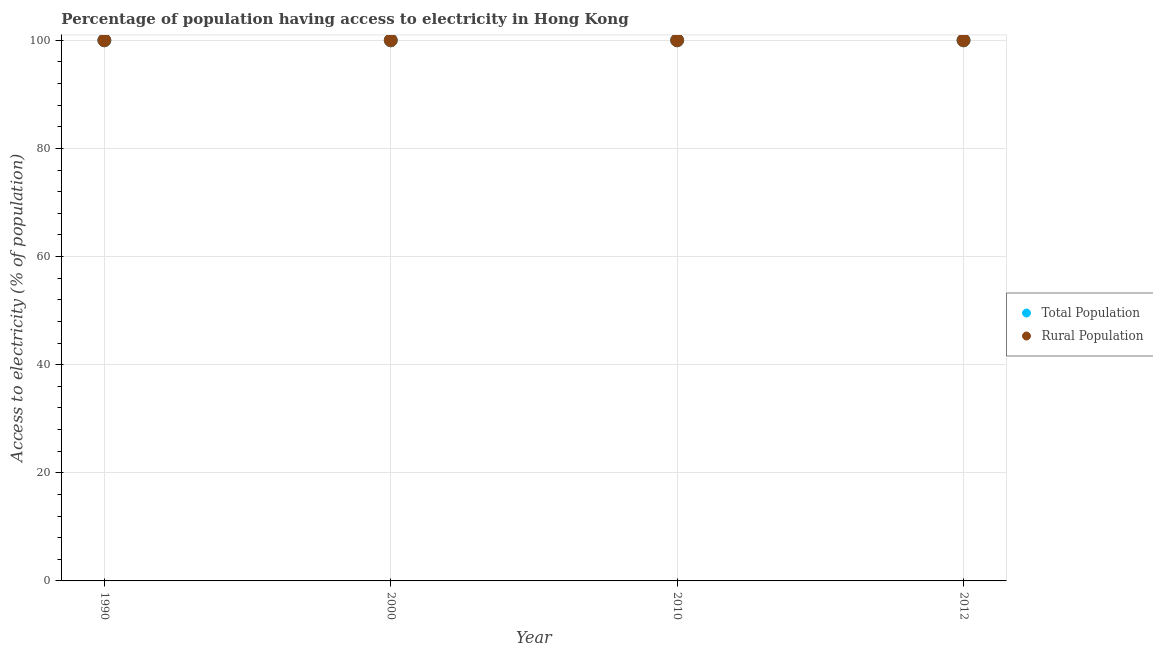How many different coloured dotlines are there?
Make the answer very short. 2. What is the percentage of population having access to electricity in 1990?
Keep it short and to the point. 100. Across all years, what is the maximum percentage of rural population having access to electricity?
Ensure brevity in your answer.  100. Across all years, what is the minimum percentage of population having access to electricity?
Offer a terse response. 100. In which year was the percentage of population having access to electricity maximum?
Make the answer very short. 1990. What is the total percentage of rural population having access to electricity in the graph?
Provide a succinct answer. 400. What is the difference between the percentage of rural population having access to electricity in 1990 and that in 2012?
Offer a terse response. 0. What is the difference between the percentage of rural population having access to electricity in 2010 and the percentage of population having access to electricity in 2000?
Offer a very short reply. 0. What is the average percentage of population having access to electricity per year?
Make the answer very short. 100. In how many years, is the percentage of population having access to electricity greater than 56 %?
Your answer should be compact. 4. Is the difference between the percentage of population having access to electricity in 2000 and 2010 greater than the difference between the percentage of rural population having access to electricity in 2000 and 2010?
Your response must be concise. No. What is the difference between the highest and the second highest percentage of rural population having access to electricity?
Provide a short and direct response. 0. In how many years, is the percentage of rural population having access to electricity greater than the average percentage of rural population having access to electricity taken over all years?
Your response must be concise. 0. Is the sum of the percentage of rural population having access to electricity in 2010 and 2012 greater than the maximum percentage of population having access to electricity across all years?
Make the answer very short. Yes. How many dotlines are there?
Keep it short and to the point. 2. What is the difference between two consecutive major ticks on the Y-axis?
Provide a short and direct response. 20. Are the values on the major ticks of Y-axis written in scientific E-notation?
Keep it short and to the point. No. How many legend labels are there?
Ensure brevity in your answer.  2. What is the title of the graph?
Your response must be concise. Percentage of population having access to electricity in Hong Kong. What is the label or title of the Y-axis?
Offer a terse response. Access to electricity (% of population). What is the Access to electricity (% of population) of Total Population in 1990?
Your response must be concise. 100. What is the Access to electricity (% of population) of Rural Population in 1990?
Your answer should be compact. 100. What is the Access to electricity (% of population) of Total Population in 2000?
Offer a terse response. 100. What is the Access to electricity (% of population) in Rural Population in 2000?
Make the answer very short. 100. What is the Access to electricity (% of population) in Total Population in 2012?
Offer a very short reply. 100. Across all years, what is the maximum Access to electricity (% of population) in Total Population?
Ensure brevity in your answer.  100. Across all years, what is the minimum Access to electricity (% of population) in Rural Population?
Your answer should be very brief. 100. What is the total Access to electricity (% of population) of Rural Population in the graph?
Ensure brevity in your answer.  400. What is the difference between the Access to electricity (% of population) of Total Population in 1990 and that in 2000?
Ensure brevity in your answer.  0. What is the difference between the Access to electricity (% of population) of Rural Population in 1990 and that in 2000?
Offer a very short reply. 0. What is the difference between the Access to electricity (% of population) in Rural Population in 1990 and that in 2010?
Make the answer very short. 0. What is the difference between the Access to electricity (% of population) of Rural Population in 1990 and that in 2012?
Your answer should be very brief. 0. What is the difference between the Access to electricity (% of population) of Total Population in 2000 and that in 2010?
Provide a succinct answer. 0. What is the difference between the Access to electricity (% of population) in Rural Population in 2000 and that in 2010?
Offer a very short reply. 0. What is the difference between the Access to electricity (% of population) in Rural Population in 2000 and that in 2012?
Keep it short and to the point. 0. What is the difference between the Access to electricity (% of population) in Total Population in 1990 and the Access to electricity (% of population) in Rural Population in 2000?
Offer a very short reply. 0. What is the difference between the Access to electricity (% of population) of Total Population in 1990 and the Access to electricity (% of population) of Rural Population in 2010?
Your answer should be very brief. 0. What is the difference between the Access to electricity (% of population) in Total Population in 1990 and the Access to electricity (% of population) in Rural Population in 2012?
Offer a very short reply. 0. What is the difference between the Access to electricity (% of population) in Total Population in 2000 and the Access to electricity (% of population) in Rural Population in 2012?
Your answer should be compact. 0. What is the average Access to electricity (% of population) of Total Population per year?
Offer a terse response. 100. In the year 1990, what is the difference between the Access to electricity (% of population) of Total Population and Access to electricity (% of population) of Rural Population?
Your response must be concise. 0. In the year 2010, what is the difference between the Access to electricity (% of population) in Total Population and Access to electricity (% of population) in Rural Population?
Your answer should be very brief. 0. In the year 2012, what is the difference between the Access to electricity (% of population) of Total Population and Access to electricity (% of population) of Rural Population?
Keep it short and to the point. 0. What is the ratio of the Access to electricity (% of population) in Total Population in 1990 to that in 2010?
Provide a succinct answer. 1. What is the ratio of the Access to electricity (% of population) of Rural Population in 1990 to that in 2010?
Make the answer very short. 1. What is the ratio of the Access to electricity (% of population) of Total Population in 1990 to that in 2012?
Offer a very short reply. 1. What is the ratio of the Access to electricity (% of population) of Rural Population in 2000 to that in 2010?
Make the answer very short. 1. What is the difference between the highest and the second highest Access to electricity (% of population) in Total Population?
Keep it short and to the point. 0. What is the difference between the highest and the second highest Access to electricity (% of population) in Rural Population?
Offer a very short reply. 0. What is the difference between the highest and the lowest Access to electricity (% of population) in Total Population?
Provide a short and direct response. 0. What is the difference between the highest and the lowest Access to electricity (% of population) in Rural Population?
Your answer should be compact. 0. 